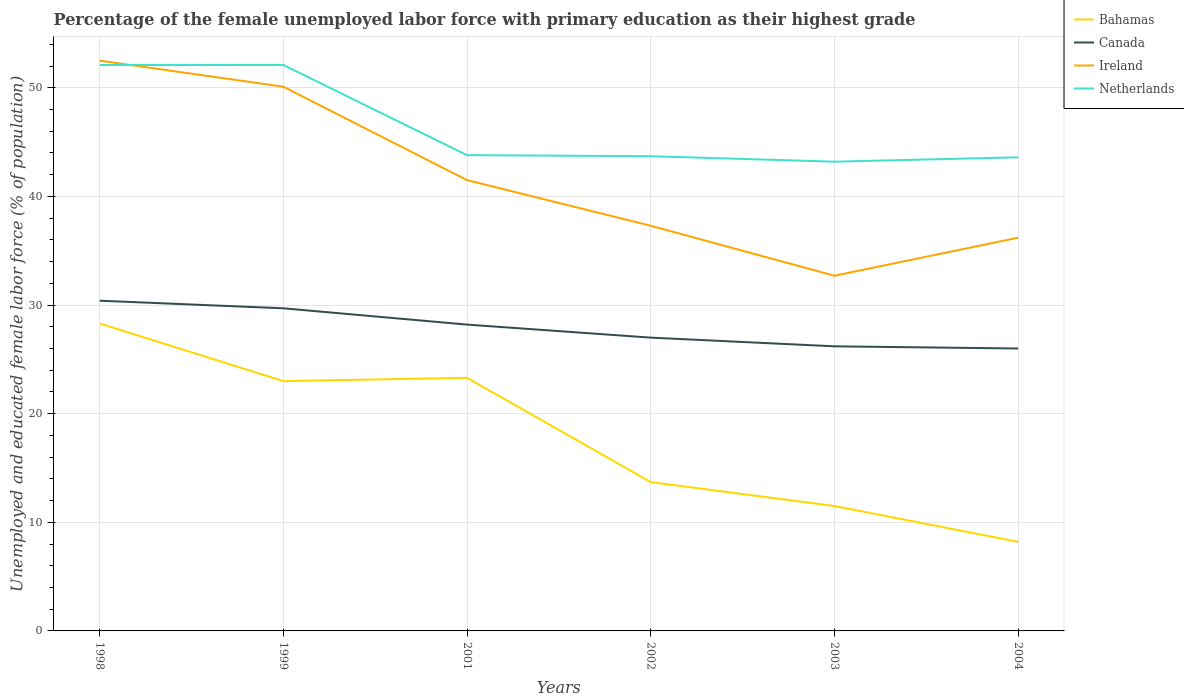Does the line corresponding to Ireland intersect with the line corresponding to Bahamas?
Ensure brevity in your answer.  No. Is the number of lines equal to the number of legend labels?
Offer a terse response. Yes. Across all years, what is the maximum percentage of the unemployed female labor force with primary education in Bahamas?
Your answer should be compact. 8.2. What is the total percentage of the unemployed female labor force with primary education in Bahamas in the graph?
Keep it short and to the point. 9.6. What is the difference between the highest and the second highest percentage of the unemployed female labor force with primary education in Ireland?
Your response must be concise. 19.8. Is the percentage of the unemployed female labor force with primary education in Bahamas strictly greater than the percentage of the unemployed female labor force with primary education in Netherlands over the years?
Your answer should be compact. Yes. Does the graph contain any zero values?
Keep it short and to the point. No. How many legend labels are there?
Provide a short and direct response. 4. What is the title of the graph?
Keep it short and to the point. Percentage of the female unemployed labor force with primary education as their highest grade. What is the label or title of the X-axis?
Your response must be concise. Years. What is the label or title of the Y-axis?
Offer a terse response. Unemployed and educated female labor force (% of population). What is the Unemployed and educated female labor force (% of population) of Bahamas in 1998?
Offer a terse response. 28.3. What is the Unemployed and educated female labor force (% of population) in Canada in 1998?
Provide a short and direct response. 30.4. What is the Unemployed and educated female labor force (% of population) of Ireland in 1998?
Your response must be concise. 52.5. What is the Unemployed and educated female labor force (% of population) of Netherlands in 1998?
Provide a short and direct response. 52.1. What is the Unemployed and educated female labor force (% of population) of Bahamas in 1999?
Offer a very short reply. 23. What is the Unemployed and educated female labor force (% of population) of Canada in 1999?
Offer a very short reply. 29.7. What is the Unemployed and educated female labor force (% of population) of Ireland in 1999?
Give a very brief answer. 50.1. What is the Unemployed and educated female labor force (% of population) in Netherlands in 1999?
Provide a short and direct response. 52.1. What is the Unemployed and educated female labor force (% of population) of Bahamas in 2001?
Provide a succinct answer. 23.3. What is the Unemployed and educated female labor force (% of population) of Canada in 2001?
Offer a very short reply. 28.2. What is the Unemployed and educated female labor force (% of population) of Ireland in 2001?
Your answer should be compact. 41.5. What is the Unemployed and educated female labor force (% of population) of Netherlands in 2001?
Give a very brief answer. 43.8. What is the Unemployed and educated female labor force (% of population) in Bahamas in 2002?
Offer a very short reply. 13.7. What is the Unemployed and educated female labor force (% of population) in Canada in 2002?
Your response must be concise. 27. What is the Unemployed and educated female labor force (% of population) in Ireland in 2002?
Your answer should be very brief. 37.3. What is the Unemployed and educated female labor force (% of population) of Netherlands in 2002?
Offer a very short reply. 43.7. What is the Unemployed and educated female labor force (% of population) in Bahamas in 2003?
Your answer should be compact. 11.5. What is the Unemployed and educated female labor force (% of population) in Canada in 2003?
Your answer should be compact. 26.2. What is the Unemployed and educated female labor force (% of population) in Ireland in 2003?
Offer a very short reply. 32.7. What is the Unemployed and educated female labor force (% of population) in Netherlands in 2003?
Your response must be concise. 43.2. What is the Unemployed and educated female labor force (% of population) in Bahamas in 2004?
Your answer should be very brief. 8.2. What is the Unemployed and educated female labor force (% of population) of Ireland in 2004?
Make the answer very short. 36.2. What is the Unemployed and educated female labor force (% of population) of Netherlands in 2004?
Your answer should be compact. 43.6. Across all years, what is the maximum Unemployed and educated female labor force (% of population) in Bahamas?
Your response must be concise. 28.3. Across all years, what is the maximum Unemployed and educated female labor force (% of population) in Canada?
Give a very brief answer. 30.4. Across all years, what is the maximum Unemployed and educated female labor force (% of population) of Ireland?
Your answer should be very brief. 52.5. Across all years, what is the maximum Unemployed and educated female labor force (% of population) of Netherlands?
Your response must be concise. 52.1. Across all years, what is the minimum Unemployed and educated female labor force (% of population) of Bahamas?
Your answer should be very brief. 8.2. Across all years, what is the minimum Unemployed and educated female labor force (% of population) in Ireland?
Your answer should be compact. 32.7. Across all years, what is the minimum Unemployed and educated female labor force (% of population) of Netherlands?
Keep it short and to the point. 43.2. What is the total Unemployed and educated female labor force (% of population) of Bahamas in the graph?
Provide a short and direct response. 108. What is the total Unemployed and educated female labor force (% of population) in Canada in the graph?
Make the answer very short. 167.5. What is the total Unemployed and educated female labor force (% of population) of Ireland in the graph?
Provide a short and direct response. 250.3. What is the total Unemployed and educated female labor force (% of population) in Netherlands in the graph?
Ensure brevity in your answer.  278.5. What is the difference between the Unemployed and educated female labor force (% of population) of Canada in 1998 and that in 1999?
Provide a succinct answer. 0.7. What is the difference between the Unemployed and educated female labor force (% of population) in Netherlands in 1998 and that in 1999?
Give a very brief answer. 0. What is the difference between the Unemployed and educated female labor force (% of population) in Canada in 1998 and that in 2001?
Your answer should be compact. 2.2. What is the difference between the Unemployed and educated female labor force (% of population) in Canada in 1998 and that in 2002?
Your answer should be compact. 3.4. What is the difference between the Unemployed and educated female labor force (% of population) of Netherlands in 1998 and that in 2002?
Your response must be concise. 8.4. What is the difference between the Unemployed and educated female labor force (% of population) of Bahamas in 1998 and that in 2003?
Your response must be concise. 16.8. What is the difference between the Unemployed and educated female labor force (% of population) of Canada in 1998 and that in 2003?
Your response must be concise. 4.2. What is the difference between the Unemployed and educated female labor force (% of population) in Ireland in 1998 and that in 2003?
Make the answer very short. 19.8. What is the difference between the Unemployed and educated female labor force (% of population) in Netherlands in 1998 and that in 2003?
Offer a terse response. 8.9. What is the difference between the Unemployed and educated female labor force (% of population) in Bahamas in 1998 and that in 2004?
Ensure brevity in your answer.  20.1. What is the difference between the Unemployed and educated female labor force (% of population) of Canada in 1998 and that in 2004?
Offer a terse response. 4.4. What is the difference between the Unemployed and educated female labor force (% of population) in Netherlands in 1998 and that in 2004?
Provide a succinct answer. 8.5. What is the difference between the Unemployed and educated female labor force (% of population) of Bahamas in 1999 and that in 2001?
Keep it short and to the point. -0.3. What is the difference between the Unemployed and educated female labor force (% of population) in Canada in 1999 and that in 2001?
Ensure brevity in your answer.  1.5. What is the difference between the Unemployed and educated female labor force (% of population) of Bahamas in 1999 and that in 2002?
Offer a terse response. 9.3. What is the difference between the Unemployed and educated female labor force (% of population) of Ireland in 1999 and that in 2002?
Your answer should be compact. 12.8. What is the difference between the Unemployed and educated female labor force (% of population) in Netherlands in 1999 and that in 2002?
Your response must be concise. 8.4. What is the difference between the Unemployed and educated female labor force (% of population) in Ireland in 1999 and that in 2004?
Offer a terse response. 13.9. What is the difference between the Unemployed and educated female labor force (% of population) of Netherlands in 1999 and that in 2004?
Your response must be concise. 8.5. What is the difference between the Unemployed and educated female labor force (% of population) in Bahamas in 2001 and that in 2002?
Make the answer very short. 9.6. What is the difference between the Unemployed and educated female labor force (% of population) of Canada in 2001 and that in 2002?
Your response must be concise. 1.2. What is the difference between the Unemployed and educated female labor force (% of population) of Ireland in 2001 and that in 2002?
Your answer should be very brief. 4.2. What is the difference between the Unemployed and educated female labor force (% of population) in Netherlands in 2001 and that in 2002?
Offer a very short reply. 0.1. What is the difference between the Unemployed and educated female labor force (% of population) of Canada in 2001 and that in 2003?
Make the answer very short. 2. What is the difference between the Unemployed and educated female labor force (% of population) in Netherlands in 2001 and that in 2003?
Provide a succinct answer. 0.6. What is the difference between the Unemployed and educated female labor force (% of population) of Ireland in 2001 and that in 2004?
Provide a succinct answer. 5.3. What is the difference between the Unemployed and educated female labor force (% of population) in Netherlands in 2001 and that in 2004?
Your answer should be compact. 0.2. What is the difference between the Unemployed and educated female labor force (% of population) of Canada in 2002 and that in 2003?
Your answer should be very brief. 0.8. What is the difference between the Unemployed and educated female labor force (% of population) in Netherlands in 2002 and that in 2003?
Your answer should be very brief. 0.5. What is the difference between the Unemployed and educated female labor force (% of population) in Bahamas in 2002 and that in 2004?
Ensure brevity in your answer.  5.5. What is the difference between the Unemployed and educated female labor force (% of population) of Canada in 2002 and that in 2004?
Your response must be concise. 1. What is the difference between the Unemployed and educated female labor force (% of population) in Netherlands in 2002 and that in 2004?
Keep it short and to the point. 0.1. What is the difference between the Unemployed and educated female labor force (% of population) of Bahamas in 1998 and the Unemployed and educated female labor force (% of population) of Canada in 1999?
Your response must be concise. -1.4. What is the difference between the Unemployed and educated female labor force (% of population) in Bahamas in 1998 and the Unemployed and educated female labor force (% of population) in Ireland in 1999?
Offer a very short reply. -21.8. What is the difference between the Unemployed and educated female labor force (% of population) in Bahamas in 1998 and the Unemployed and educated female labor force (% of population) in Netherlands in 1999?
Offer a terse response. -23.8. What is the difference between the Unemployed and educated female labor force (% of population) of Canada in 1998 and the Unemployed and educated female labor force (% of population) of Ireland in 1999?
Offer a very short reply. -19.7. What is the difference between the Unemployed and educated female labor force (% of population) of Canada in 1998 and the Unemployed and educated female labor force (% of population) of Netherlands in 1999?
Provide a succinct answer. -21.7. What is the difference between the Unemployed and educated female labor force (% of population) of Bahamas in 1998 and the Unemployed and educated female labor force (% of population) of Canada in 2001?
Your response must be concise. 0.1. What is the difference between the Unemployed and educated female labor force (% of population) in Bahamas in 1998 and the Unemployed and educated female labor force (% of population) in Ireland in 2001?
Your response must be concise. -13.2. What is the difference between the Unemployed and educated female labor force (% of population) of Bahamas in 1998 and the Unemployed and educated female labor force (% of population) of Netherlands in 2001?
Your answer should be very brief. -15.5. What is the difference between the Unemployed and educated female labor force (% of population) of Canada in 1998 and the Unemployed and educated female labor force (% of population) of Netherlands in 2001?
Your answer should be very brief. -13.4. What is the difference between the Unemployed and educated female labor force (% of population) in Bahamas in 1998 and the Unemployed and educated female labor force (% of population) in Ireland in 2002?
Offer a terse response. -9. What is the difference between the Unemployed and educated female labor force (% of population) of Bahamas in 1998 and the Unemployed and educated female labor force (% of population) of Netherlands in 2002?
Your answer should be very brief. -15.4. What is the difference between the Unemployed and educated female labor force (% of population) in Ireland in 1998 and the Unemployed and educated female labor force (% of population) in Netherlands in 2002?
Offer a very short reply. 8.8. What is the difference between the Unemployed and educated female labor force (% of population) of Bahamas in 1998 and the Unemployed and educated female labor force (% of population) of Canada in 2003?
Give a very brief answer. 2.1. What is the difference between the Unemployed and educated female labor force (% of population) in Bahamas in 1998 and the Unemployed and educated female labor force (% of population) in Ireland in 2003?
Offer a terse response. -4.4. What is the difference between the Unemployed and educated female labor force (% of population) of Bahamas in 1998 and the Unemployed and educated female labor force (% of population) of Netherlands in 2003?
Offer a terse response. -14.9. What is the difference between the Unemployed and educated female labor force (% of population) of Ireland in 1998 and the Unemployed and educated female labor force (% of population) of Netherlands in 2003?
Keep it short and to the point. 9.3. What is the difference between the Unemployed and educated female labor force (% of population) in Bahamas in 1998 and the Unemployed and educated female labor force (% of population) in Canada in 2004?
Your response must be concise. 2.3. What is the difference between the Unemployed and educated female labor force (% of population) in Bahamas in 1998 and the Unemployed and educated female labor force (% of population) in Ireland in 2004?
Offer a very short reply. -7.9. What is the difference between the Unemployed and educated female labor force (% of population) in Bahamas in 1998 and the Unemployed and educated female labor force (% of population) in Netherlands in 2004?
Offer a terse response. -15.3. What is the difference between the Unemployed and educated female labor force (% of population) of Canada in 1998 and the Unemployed and educated female labor force (% of population) of Ireland in 2004?
Provide a short and direct response. -5.8. What is the difference between the Unemployed and educated female labor force (% of population) in Canada in 1998 and the Unemployed and educated female labor force (% of population) in Netherlands in 2004?
Ensure brevity in your answer.  -13.2. What is the difference between the Unemployed and educated female labor force (% of population) of Bahamas in 1999 and the Unemployed and educated female labor force (% of population) of Ireland in 2001?
Give a very brief answer. -18.5. What is the difference between the Unemployed and educated female labor force (% of population) in Bahamas in 1999 and the Unemployed and educated female labor force (% of population) in Netherlands in 2001?
Offer a terse response. -20.8. What is the difference between the Unemployed and educated female labor force (% of population) of Canada in 1999 and the Unemployed and educated female labor force (% of population) of Netherlands in 2001?
Give a very brief answer. -14.1. What is the difference between the Unemployed and educated female labor force (% of population) in Ireland in 1999 and the Unemployed and educated female labor force (% of population) in Netherlands in 2001?
Offer a very short reply. 6.3. What is the difference between the Unemployed and educated female labor force (% of population) of Bahamas in 1999 and the Unemployed and educated female labor force (% of population) of Ireland in 2002?
Your response must be concise. -14.3. What is the difference between the Unemployed and educated female labor force (% of population) of Bahamas in 1999 and the Unemployed and educated female labor force (% of population) of Netherlands in 2002?
Ensure brevity in your answer.  -20.7. What is the difference between the Unemployed and educated female labor force (% of population) of Canada in 1999 and the Unemployed and educated female labor force (% of population) of Ireland in 2002?
Make the answer very short. -7.6. What is the difference between the Unemployed and educated female labor force (% of population) in Bahamas in 1999 and the Unemployed and educated female labor force (% of population) in Canada in 2003?
Give a very brief answer. -3.2. What is the difference between the Unemployed and educated female labor force (% of population) in Bahamas in 1999 and the Unemployed and educated female labor force (% of population) in Ireland in 2003?
Your answer should be compact. -9.7. What is the difference between the Unemployed and educated female labor force (% of population) of Bahamas in 1999 and the Unemployed and educated female labor force (% of population) of Netherlands in 2003?
Make the answer very short. -20.2. What is the difference between the Unemployed and educated female labor force (% of population) in Canada in 1999 and the Unemployed and educated female labor force (% of population) in Ireland in 2003?
Your answer should be compact. -3. What is the difference between the Unemployed and educated female labor force (% of population) of Canada in 1999 and the Unemployed and educated female labor force (% of population) of Netherlands in 2003?
Your response must be concise. -13.5. What is the difference between the Unemployed and educated female labor force (% of population) of Bahamas in 1999 and the Unemployed and educated female labor force (% of population) of Canada in 2004?
Give a very brief answer. -3. What is the difference between the Unemployed and educated female labor force (% of population) in Bahamas in 1999 and the Unemployed and educated female labor force (% of population) in Ireland in 2004?
Your answer should be compact. -13.2. What is the difference between the Unemployed and educated female labor force (% of population) in Bahamas in 1999 and the Unemployed and educated female labor force (% of population) in Netherlands in 2004?
Your answer should be very brief. -20.6. What is the difference between the Unemployed and educated female labor force (% of population) of Bahamas in 2001 and the Unemployed and educated female labor force (% of population) of Canada in 2002?
Provide a short and direct response. -3.7. What is the difference between the Unemployed and educated female labor force (% of population) in Bahamas in 2001 and the Unemployed and educated female labor force (% of population) in Netherlands in 2002?
Your answer should be very brief. -20.4. What is the difference between the Unemployed and educated female labor force (% of population) in Canada in 2001 and the Unemployed and educated female labor force (% of population) in Netherlands in 2002?
Give a very brief answer. -15.5. What is the difference between the Unemployed and educated female labor force (% of population) in Ireland in 2001 and the Unemployed and educated female labor force (% of population) in Netherlands in 2002?
Make the answer very short. -2.2. What is the difference between the Unemployed and educated female labor force (% of population) of Bahamas in 2001 and the Unemployed and educated female labor force (% of population) of Canada in 2003?
Make the answer very short. -2.9. What is the difference between the Unemployed and educated female labor force (% of population) of Bahamas in 2001 and the Unemployed and educated female labor force (% of population) of Netherlands in 2003?
Offer a terse response. -19.9. What is the difference between the Unemployed and educated female labor force (% of population) in Canada in 2001 and the Unemployed and educated female labor force (% of population) in Ireland in 2003?
Your answer should be very brief. -4.5. What is the difference between the Unemployed and educated female labor force (% of population) of Canada in 2001 and the Unemployed and educated female labor force (% of population) of Netherlands in 2003?
Give a very brief answer. -15. What is the difference between the Unemployed and educated female labor force (% of population) in Ireland in 2001 and the Unemployed and educated female labor force (% of population) in Netherlands in 2003?
Offer a terse response. -1.7. What is the difference between the Unemployed and educated female labor force (% of population) of Bahamas in 2001 and the Unemployed and educated female labor force (% of population) of Canada in 2004?
Provide a succinct answer. -2.7. What is the difference between the Unemployed and educated female labor force (% of population) of Bahamas in 2001 and the Unemployed and educated female labor force (% of population) of Netherlands in 2004?
Your answer should be compact. -20.3. What is the difference between the Unemployed and educated female labor force (% of population) in Canada in 2001 and the Unemployed and educated female labor force (% of population) in Netherlands in 2004?
Your response must be concise. -15.4. What is the difference between the Unemployed and educated female labor force (% of population) in Ireland in 2001 and the Unemployed and educated female labor force (% of population) in Netherlands in 2004?
Make the answer very short. -2.1. What is the difference between the Unemployed and educated female labor force (% of population) of Bahamas in 2002 and the Unemployed and educated female labor force (% of population) of Netherlands in 2003?
Give a very brief answer. -29.5. What is the difference between the Unemployed and educated female labor force (% of population) of Canada in 2002 and the Unemployed and educated female labor force (% of population) of Netherlands in 2003?
Your answer should be compact. -16.2. What is the difference between the Unemployed and educated female labor force (% of population) of Ireland in 2002 and the Unemployed and educated female labor force (% of population) of Netherlands in 2003?
Keep it short and to the point. -5.9. What is the difference between the Unemployed and educated female labor force (% of population) in Bahamas in 2002 and the Unemployed and educated female labor force (% of population) in Canada in 2004?
Provide a succinct answer. -12.3. What is the difference between the Unemployed and educated female labor force (% of population) in Bahamas in 2002 and the Unemployed and educated female labor force (% of population) in Ireland in 2004?
Your answer should be compact. -22.5. What is the difference between the Unemployed and educated female labor force (% of population) of Bahamas in 2002 and the Unemployed and educated female labor force (% of population) of Netherlands in 2004?
Keep it short and to the point. -29.9. What is the difference between the Unemployed and educated female labor force (% of population) of Canada in 2002 and the Unemployed and educated female labor force (% of population) of Ireland in 2004?
Make the answer very short. -9.2. What is the difference between the Unemployed and educated female labor force (% of population) of Canada in 2002 and the Unemployed and educated female labor force (% of population) of Netherlands in 2004?
Make the answer very short. -16.6. What is the difference between the Unemployed and educated female labor force (% of population) in Bahamas in 2003 and the Unemployed and educated female labor force (% of population) in Ireland in 2004?
Offer a terse response. -24.7. What is the difference between the Unemployed and educated female labor force (% of population) in Bahamas in 2003 and the Unemployed and educated female labor force (% of population) in Netherlands in 2004?
Give a very brief answer. -32.1. What is the difference between the Unemployed and educated female labor force (% of population) of Canada in 2003 and the Unemployed and educated female labor force (% of population) of Netherlands in 2004?
Keep it short and to the point. -17.4. What is the difference between the Unemployed and educated female labor force (% of population) of Ireland in 2003 and the Unemployed and educated female labor force (% of population) of Netherlands in 2004?
Give a very brief answer. -10.9. What is the average Unemployed and educated female labor force (% of population) of Bahamas per year?
Your answer should be compact. 18. What is the average Unemployed and educated female labor force (% of population) of Canada per year?
Make the answer very short. 27.92. What is the average Unemployed and educated female labor force (% of population) in Ireland per year?
Provide a succinct answer. 41.72. What is the average Unemployed and educated female labor force (% of population) of Netherlands per year?
Provide a succinct answer. 46.42. In the year 1998, what is the difference between the Unemployed and educated female labor force (% of population) of Bahamas and Unemployed and educated female labor force (% of population) of Ireland?
Keep it short and to the point. -24.2. In the year 1998, what is the difference between the Unemployed and educated female labor force (% of population) of Bahamas and Unemployed and educated female labor force (% of population) of Netherlands?
Your answer should be compact. -23.8. In the year 1998, what is the difference between the Unemployed and educated female labor force (% of population) in Canada and Unemployed and educated female labor force (% of population) in Ireland?
Your response must be concise. -22.1. In the year 1998, what is the difference between the Unemployed and educated female labor force (% of population) in Canada and Unemployed and educated female labor force (% of population) in Netherlands?
Offer a very short reply. -21.7. In the year 1998, what is the difference between the Unemployed and educated female labor force (% of population) in Ireland and Unemployed and educated female labor force (% of population) in Netherlands?
Make the answer very short. 0.4. In the year 1999, what is the difference between the Unemployed and educated female labor force (% of population) of Bahamas and Unemployed and educated female labor force (% of population) of Ireland?
Your answer should be very brief. -27.1. In the year 1999, what is the difference between the Unemployed and educated female labor force (% of population) in Bahamas and Unemployed and educated female labor force (% of population) in Netherlands?
Your answer should be very brief. -29.1. In the year 1999, what is the difference between the Unemployed and educated female labor force (% of population) in Canada and Unemployed and educated female labor force (% of population) in Ireland?
Your answer should be very brief. -20.4. In the year 1999, what is the difference between the Unemployed and educated female labor force (% of population) in Canada and Unemployed and educated female labor force (% of population) in Netherlands?
Offer a terse response. -22.4. In the year 2001, what is the difference between the Unemployed and educated female labor force (% of population) of Bahamas and Unemployed and educated female labor force (% of population) of Canada?
Make the answer very short. -4.9. In the year 2001, what is the difference between the Unemployed and educated female labor force (% of population) of Bahamas and Unemployed and educated female labor force (% of population) of Ireland?
Offer a terse response. -18.2. In the year 2001, what is the difference between the Unemployed and educated female labor force (% of population) in Bahamas and Unemployed and educated female labor force (% of population) in Netherlands?
Your answer should be very brief. -20.5. In the year 2001, what is the difference between the Unemployed and educated female labor force (% of population) in Canada and Unemployed and educated female labor force (% of population) in Ireland?
Your response must be concise. -13.3. In the year 2001, what is the difference between the Unemployed and educated female labor force (% of population) of Canada and Unemployed and educated female labor force (% of population) of Netherlands?
Keep it short and to the point. -15.6. In the year 2001, what is the difference between the Unemployed and educated female labor force (% of population) in Ireland and Unemployed and educated female labor force (% of population) in Netherlands?
Offer a terse response. -2.3. In the year 2002, what is the difference between the Unemployed and educated female labor force (% of population) of Bahamas and Unemployed and educated female labor force (% of population) of Ireland?
Your answer should be very brief. -23.6. In the year 2002, what is the difference between the Unemployed and educated female labor force (% of population) of Canada and Unemployed and educated female labor force (% of population) of Netherlands?
Provide a short and direct response. -16.7. In the year 2003, what is the difference between the Unemployed and educated female labor force (% of population) in Bahamas and Unemployed and educated female labor force (% of population) in Canada?
Ensure brevity in your answer.  -14.7. In the year 2003, what is the difference between the Unemployed and educated female labor force (% of population) in Bahamas and Unemployed and educated female labor force (% of population) in Ireland?
Your answer should be compact. -21.2. In the year 2003, what is the difference between the Unemployed and educated female labor force (% of population) of Bahamas and Unemployed and educated female labor force (% of population) of Netherlands?
Your answer should be compact. -31.7. In the year 2004, what is the difference between the Unemployed and educated female labor force (% of population) of Bahamas and Unemployed and educated female labor force (% of population) of Canada?
Make the answer very short. -17.8. In the year 2004, what is the difference between the Unemployed and educated female labor force (% of population) of Bahamas and Unemployed and educated female labor force (% of population) of Netherlands?
Make the answer very short. -35.4. In the year 2004, what is the difference between the Unemployed and educated female labor force (% of population) of Canada and Unemployed and educated female labor force (% of population) of Ireland?
Your answer should be very brief. -10.2. In the year 2004, what is the difference between the Unemployed and educated female labor force (% of population) of Canada and Unemployed and educated female labor force (% of population) of Netherlands?
Your answer should be compact. -17.6. What is the ratio of the Unemployed and educated female labor force (% of population) of Bahamas in 1998 to that in 1999?
Make the answer very short. 1.23. What is the ratio of the Unemployed and educated female labor force (% of population) of Canada in 1998 to that in 1999?
Your answer should be very brief. 1.02. What is the ratio of the Unemployed and educated female labor force (% of population) in Ireland in 1998 to that in 1999?
Your answer should be very brief. 1.05. What is the ratio of the Unemployed and educated female labor force (% of population) in Netherlands in 1998 to that in 1999?
Provide a succinct answer. 1. What is the ratio of the Unemployed and educated female labor force (% of population) of Bahamas in 1998 to that in 2001?
Provide a short and direct response. 1.21. What is the ratio of the Unemployed and educated female labor force (% of population) in Canada in 1998 to that in 2001?
Your answer should be very brief. 1.08. What is the ratio of the Unemployed and educated female labor force (% of population) of Ireland in 1998 to that in 2001?
Your response must be concise. 1.27. What is the ratio of the Unemployed and educated female labor force (% of population) in Netherlands in 1998 to that in 2001?
Give a very brief answer. 1.19. What is the ratio of the Unemployed and educated female labor force (% of population) of Bahamas in 1998 to that in 2002?
Keep it short and to the point. 2.07. What is the ratio of the Unemployed and educated female labor force (% of population) of Canada in 1998 to that in 2002?
Your answer should be compact. 1.13. What is the ratio of the Unemployed and educated female labor force (% of population) in Ireland in 1998 to that in 2002?
Make the answer very short. 1.41. What is the ratio of the Unemployed and educated female labor force (% of population) of Netherlands in 1998 to that in 2002?
Give a very brief answer. 1.19. What is the ratio of the Unemployed and educated female labor force (% of population) of Bahamas in 1998 to that in 2003?
Give a very brief answer. 2.46. What is the ratio of the Unemployed and educated female labor force (% of population) in Canada in 1998 to that in 2003?
Your response must be concise. 1.16. What is the ratio of the Unemployed and educated female labor force (% of population) in Ireland in 1998 to that in 2003?
Offer a very short reply. 1.61. What is the ratio of the Unemployed and educated female labor force (% of population) in Netherlands in 1998 to that in 2003?
Provide a short and direct response. 1.21. What is the ratio of the Unemployed and educated female labor force (% of population) in Bahamas in 1998 to that in 2004?
Your answer should be very brief. 3.45. What is the ratio of the Unemployed and educated female labor force (% of population) in Canada in 1998 to that in 2004?
Your answer should be compact. 1.17. What is the ratio of the Unemployed and educated female labor force (% of population) in Ireland in 1998 to that in 2004?
Keep it short and to the point. 1.45. What is the ratio of the Unemployed and educated female labor force (% of population) in Netherlands in 1998 to that in 2004?
Ensure brevity in your answer.  1.2. What is the ratio of the Unemployed and educated female labor force (% of population) in Bahamas in 1999 to that in 2001?
Give a very brief answer. 0.99. What is the ratio of the Unemployed and educated female labor force (% of population) in Canada in 1999 to that in 2001?
Your response must be concise. 1.05. What is the ratio of the Unemployed and educated female labor force (% of population) of Ireland in 1999 to that in 2001?
Ensure brevity in your answer.  1.21. What is the ratio of the Unemployed and educated female labor force (% of population) in Netherlands in 1999 to that in 2001?
Keep it short and to the point. 1.19. What is the ratio of the Unemployed and educated female labor force (% of population) in Bahamas in 1999 to that in 2002?
Your answer should be compact. 1.68. What is the ratio of the Unemployed and educated female labor force (% of population) in Canada in 1999 to that in 2002?
Your answer should be very brief. 1.1. What is the ratio of the Unemployed and educated female labor force (% of population) in Ireland in 1999 to that in 2002?
Make the answer very short. 1.34. What is the ratio of the Unemployed and educated female labor force (% of population) in Netherlands in 1999 to that in 2002?
Your response must be concise. 1.19. What is the ratio of the Unemployed and educated female labor force (% of population) in Bahamas in 1999 to that in 2003?
Make the answer very short. 2. What is the ratio of the Unemployed and educated female labor force (% of population) in Canada in 1999 to that in 2003?
Ensure brevity in your answer.  1.13. What is the ratio of the Unemployed and educated female labor force (% of population) in Ireland in 1999 to that in 2003?
Keep it short and to the point. 1.53. What is the ratio of the Unemployed and educated female labor force (% of population) of Netherlands in 1999 to that in 2003?
Keep it short and to the point. 1.21. What is the ratio of the Unemployed and educated female labor force (% of population) of Bahamas in 1999 to that in 2004?
Keep it short and to the point. 2.8. What is the ratio of the Unemployed and educated female labor force (% of population) of Canada in 1999 to that in 2004?
Keep it short and to the point. 1.14. What is the ratio of the Unemployed and educated female labor force (% of population) of Ireland in 1999 to that in 2004?
Provide a succinct answer. 1.38. What is the ratio of the Unemployed and educated female labor force (% of population) in Netherlands in 1999 to that in 2004?
Ensure brevity in your answer.  1.2. What is the ratio of the Unemployed and educated female labor force (% of population) in Bahamas in 2001 to that in 2002?
Your answer should be very brief. 1.7. What is the ratio of the Unemployed and educated female labor force (% of population) in Canada in 2001 to that in 2002?
Make the answer very short. 1.04. What is the ratio of the Unemployed and educated female labor force (% of population) in Ireland in 2001 to that in 2002?
Keep it short and to the point. 1.11. What is the ratio of the Unemployed and educated female labor force (% of population) of Bahamas in 2001 to that in 2003?
Offer a terse response. 2.03. What is the ratio of the Unemployed and educated female labor force (% of population) of Canada in 2001 to that in 2003?
Your answer should be compact. 1.08. What is the ratio of the Unemployed and educated female labor force (% of population) in Ireland in 2001 to that in 2003?
Offer a terse response. 1.27. What is the ratio of the Unemployed and educated female labor force (% of population) of Netherlands in 2001 to that in 2003?
Your answer should be very brief. 1.01. What is the ratio of the Unemployed and educated female labor force (% of population) of Bahamas in 2001 to that in 2004?
Offer a terse response. 2.84. What is the ratio of the Unemployed and educated female labor force (% of population) of Canada in 2001 to that in 2004?
Ensure brevity in your answer.  1.08. What is the ratio of the Unemployed and educated female labor force (% of population) of Ireland in 2001 to that in 2004?
Your response must be concise. 1.15. What is the ratio of the Unemployed and educated female labor force (% of population) of Bahamas in 2002 to that in 2003?
Give a very brief answer. 1.19. What is the ratio of the Unemployed and educated female labor force (% of population) in Canada in 2002 to that in 2003?
Provide a succinct answer. 1.03. What is the ratio of the Unemployed and educated female labor force (% of population) of Ireland in 2002 to that in 2003?
Offer a very short reply. 1.14. What is the ratio of the Unemployed and educated female labor force (% of population) in Netherlands in 2002 to that in 2003?
Keep it short and to the point. 1.01. What is the ratio of the Unemployed and educated female labor force (% of population) in Bahamas in 2002 to that in 2004?
Keep it short and to the point. 1.67. What is the ratio of the Unemployed and educated female labor force (% of population) of Ireland in 2002 to that in 2004?
Your answer should be compact. 1.03. What is the ratio of the Unemployed and educated female labor force (% of population) in Bahamas in 2003 to that in 2004?
Offer a very short reply. 1.4. What is the ratio of the Unemployed and educated female labor force (% of population) of Canada in 2003 to that in 2004?
Your answer should be compact. 1.01. What is the ratio of the Unemployed and educated female labor force (% of population) of Ireland in 2003 to that in 2004?
Make the answer very short. 0.9. What is the ratio of the Unemployed and educated female labor force (% of population) in Netherlands in 2003 to that in 2004?
Your response must be concise. 0.99. What is the difference between the highest and the second highest Unemployed and educated female labor force (% of population) in Bahamas?
Offer a very short reply. 5. What is the difference between the highest and the second highest Unemployed and educated female labor force (% of population) in Netherlands?
Make the answer very short. 0. What is the difference between the highest and the lowest Unemployed and educated female labor force (% of population) of Bahamas?
Offer a very short reply. 20.1. What is the difference between the highest and the lowest Unemployed and educated female labor force (% of population) of Ireland?
Keep it short and to the point. 19.8. What is the difference between the highest and the lowest Unemployed and educated female labor force (% of population) in Netherlands?
Ensure brevity in your answer.  8.9. 